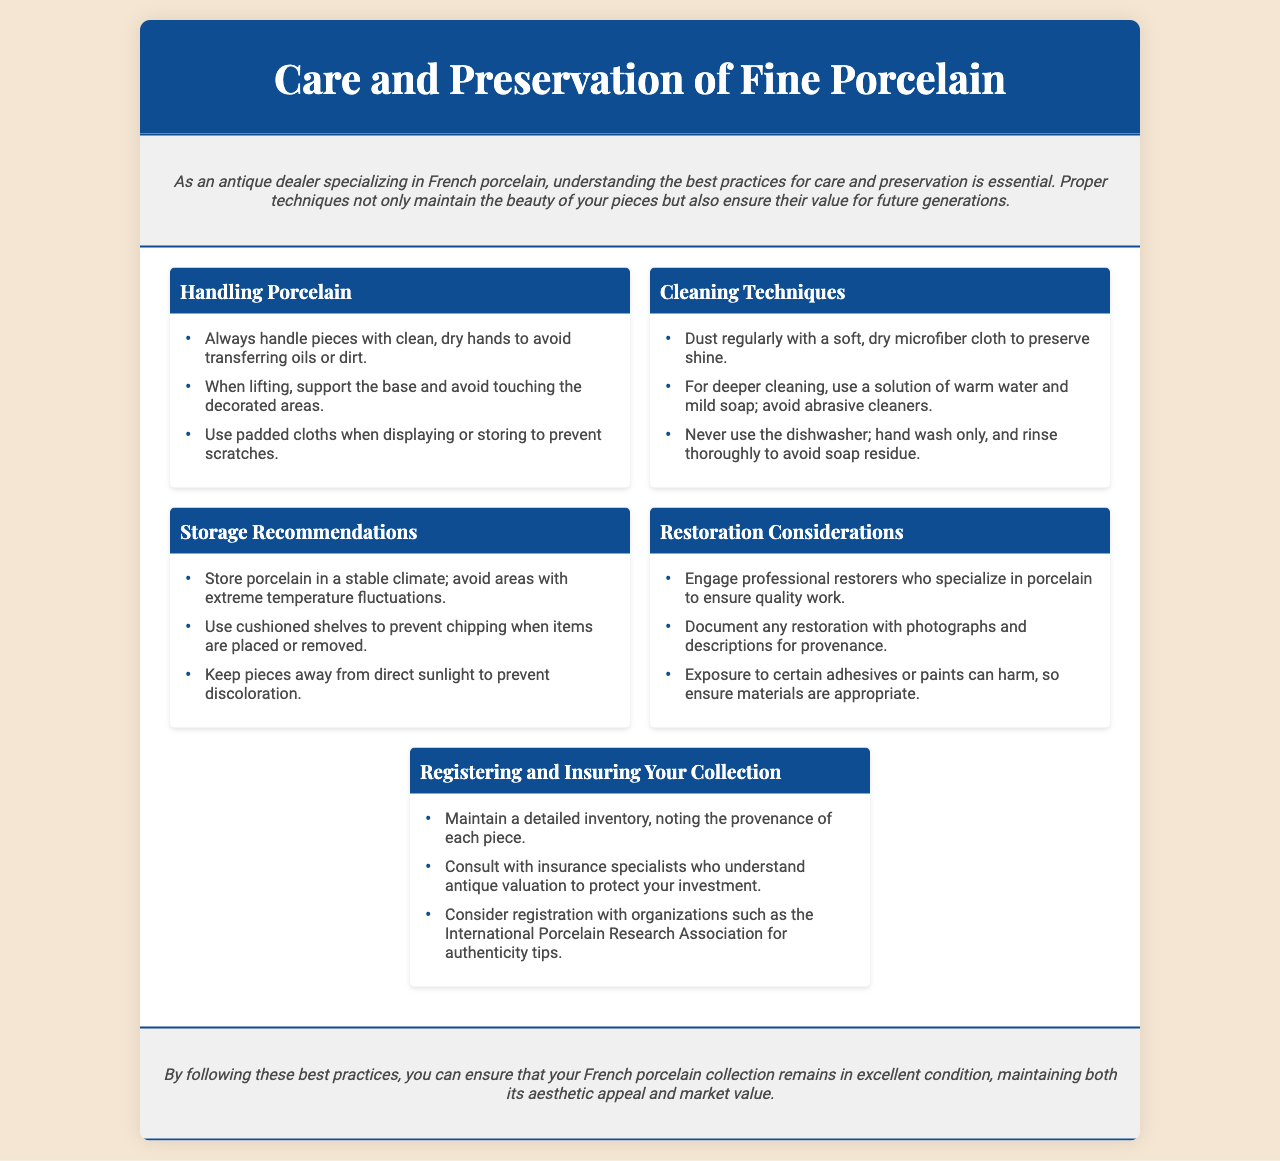What is the title of the brochure? The title is "Care and Preservation of Fine Porcelain," which effectively describes the topic of the document.
Answer: Care and Preservation of Fine Porcelain How many main sections are in the content? The document includes five sections that cover various aspects of caring for porcelain.
Answer: Five What should you avoid when cleaning porcelain? The document states that abrasive cleaners should be avoided when cleaning porcelain, highlighting a specific cleaning tip.
Answer: Abrasive cleaners Who should you engage for restoration? The document advises engaging professional restorers who specialize in porcelain to ensure quality restoration work.
Answer: Professional restorers What type of cloth is recommended for dusting? A soft, dry microfiber cloth is recommended for dusting to help preserve shine without scratching the surface.
Answer: Microfiber cloth What can be used to document restoration work? Photographs and descriptions can be used to document restoration work, according to the recommendations for maintaining provenance.
Answer: Photographs and descriptions Where should porcelain be stored to avoid temperature issues? The document suggests storing porcelain in a stable climate, emphasizing a specific storage recommendation for preservation.
Answer: Stable climate Which organization is mentioned for authenticity tips? The International Porcelain Research Association is mentioned for authenticity tips, a relevant resource for collectors.
Answer: International Porcelain Research Association 